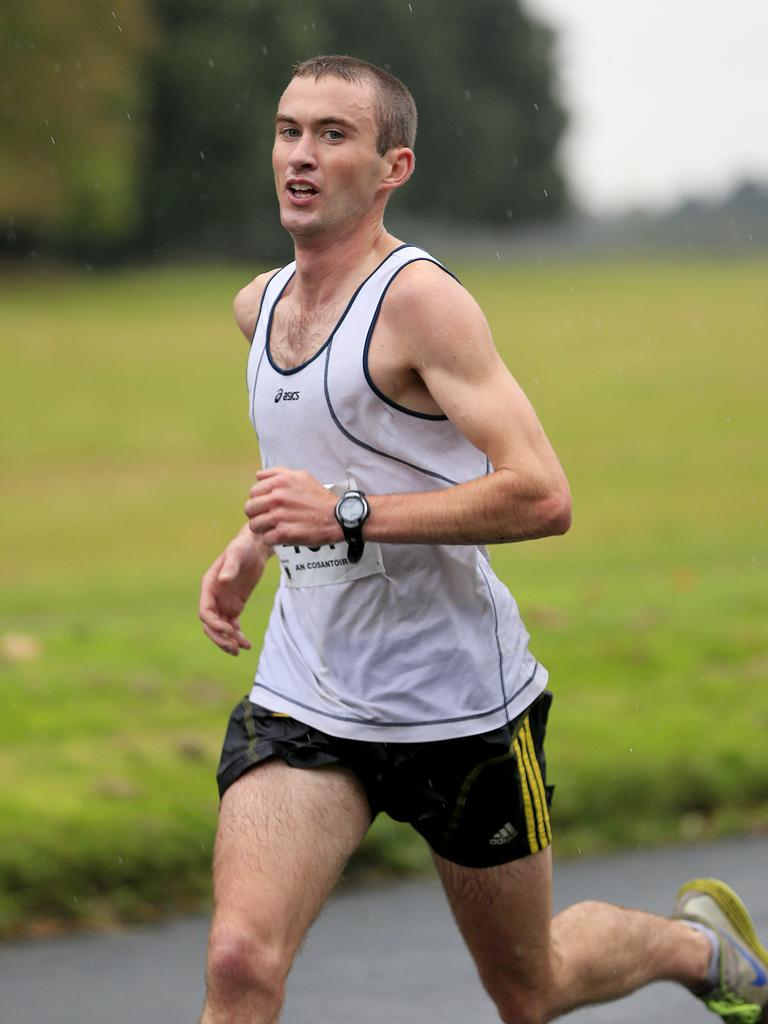<image>
Summarize the visual content of the image. A man is jogging while wearing a shirt that says asics on it. 